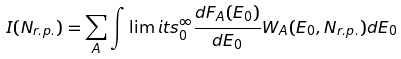Convert formula to latex. <formula><loc_0><loc_0><loc_500><loc_500>I ( N _ { r . p . } ) = \sum _ { A } \int \lim i t s _ { 0 } ^ { \infty } \frac { d F _ { A } ( E _ { 0 } ) } { d E _ { 0 } } W _ { A } ( E _ { 0 } , N _ { r . p . } ) d E _ { 0 }</formula> 